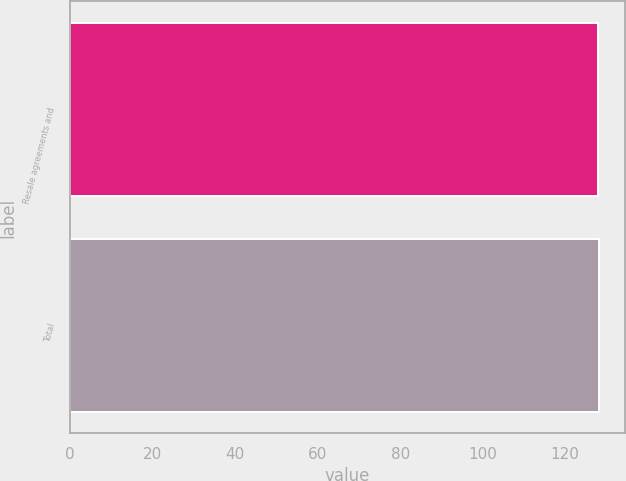Convert chart. <chart><loc_0><loc_0><loc_500><loc_500><bar_chart><fcel>Resale agreements and<fcel>Total<nl><fcel>128<fcel>128.1<nl></chart> 